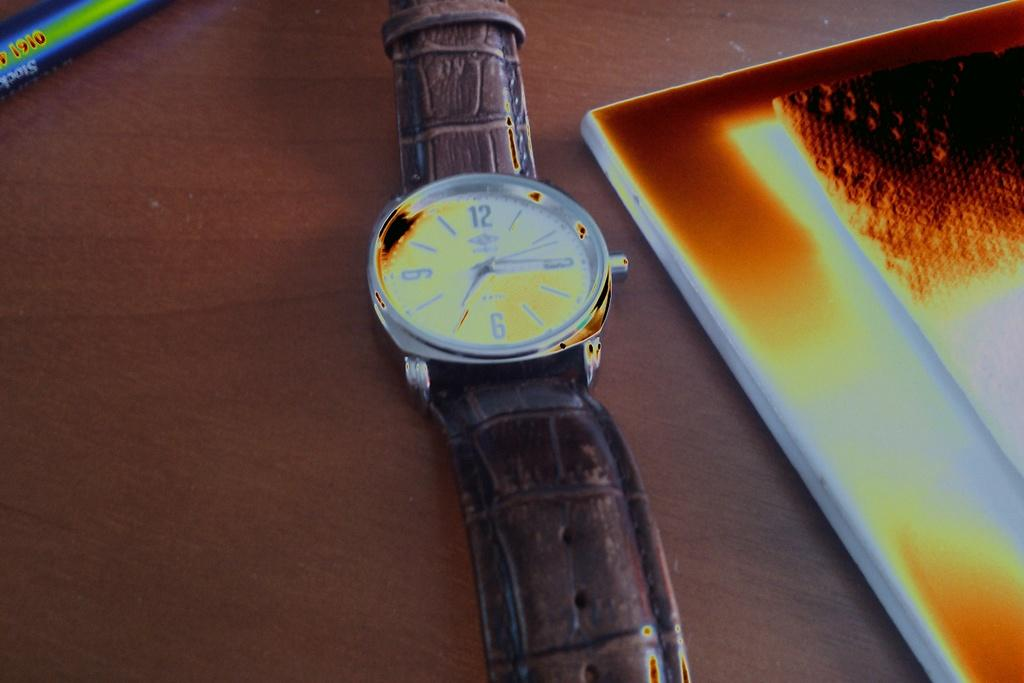<image>
Create a compact narrative representing the image presented. A wrist watch showing the time a quarter past seven lays on a table. 